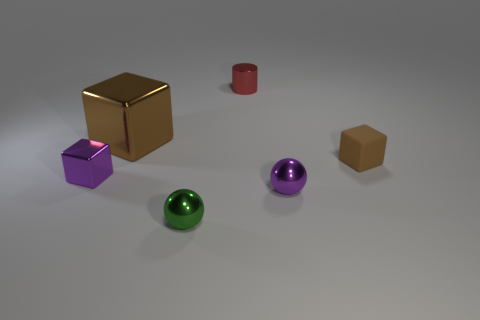Subtract all purple blocks. How many blocks are left? 2 Subtract all metallic cubes. How many cubes are left? 1 Subtract 1 spheres. How many spheres are left? 1 Add 4 matte blocks. How many matte blocks are left? 5 Add 4 tiny green shiny spheres. How many tiny green shiny spheres exist? 5 Add 3 green objects. How many objects exist? 9 Subtract 0 brown balls. How many objects are left? 6 Subtract all spheres. How many objects are left? 4 Subtract all yellow spheres. Subtract all cyan blocks. How many spheres are left? 2 Subtract all blue cubes. How many brown spheres are left? 0 